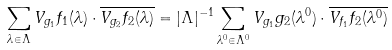Convert formula to latex. <formula><loc_0><loc_0><loc_500><loc_500>\sum _ { \lambda \in \Lambda } V _ { g _ { 1 } } f _ { 1 } ( \lambda ) \cdot \overline { V _ { g _ { 2 } } f _ { 2 } ( \lambda ) } = | \Lambda | ^ { - 1 } \sum _ { \lambda ^ { 0 } \in \Lambda ^ { 0 } } V _ { g _ { 1 } } g _ { 2 } ( \lambda ^ { 0 } ) \cdot \overline { V _ { f _ { 1 } } f _ { 2 } ( \lambda ^ { 0 } ) }</formula> 